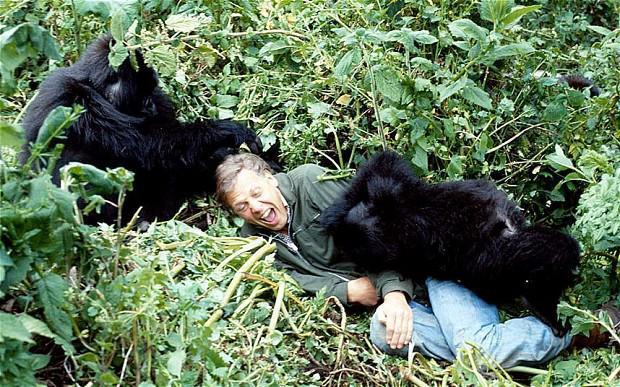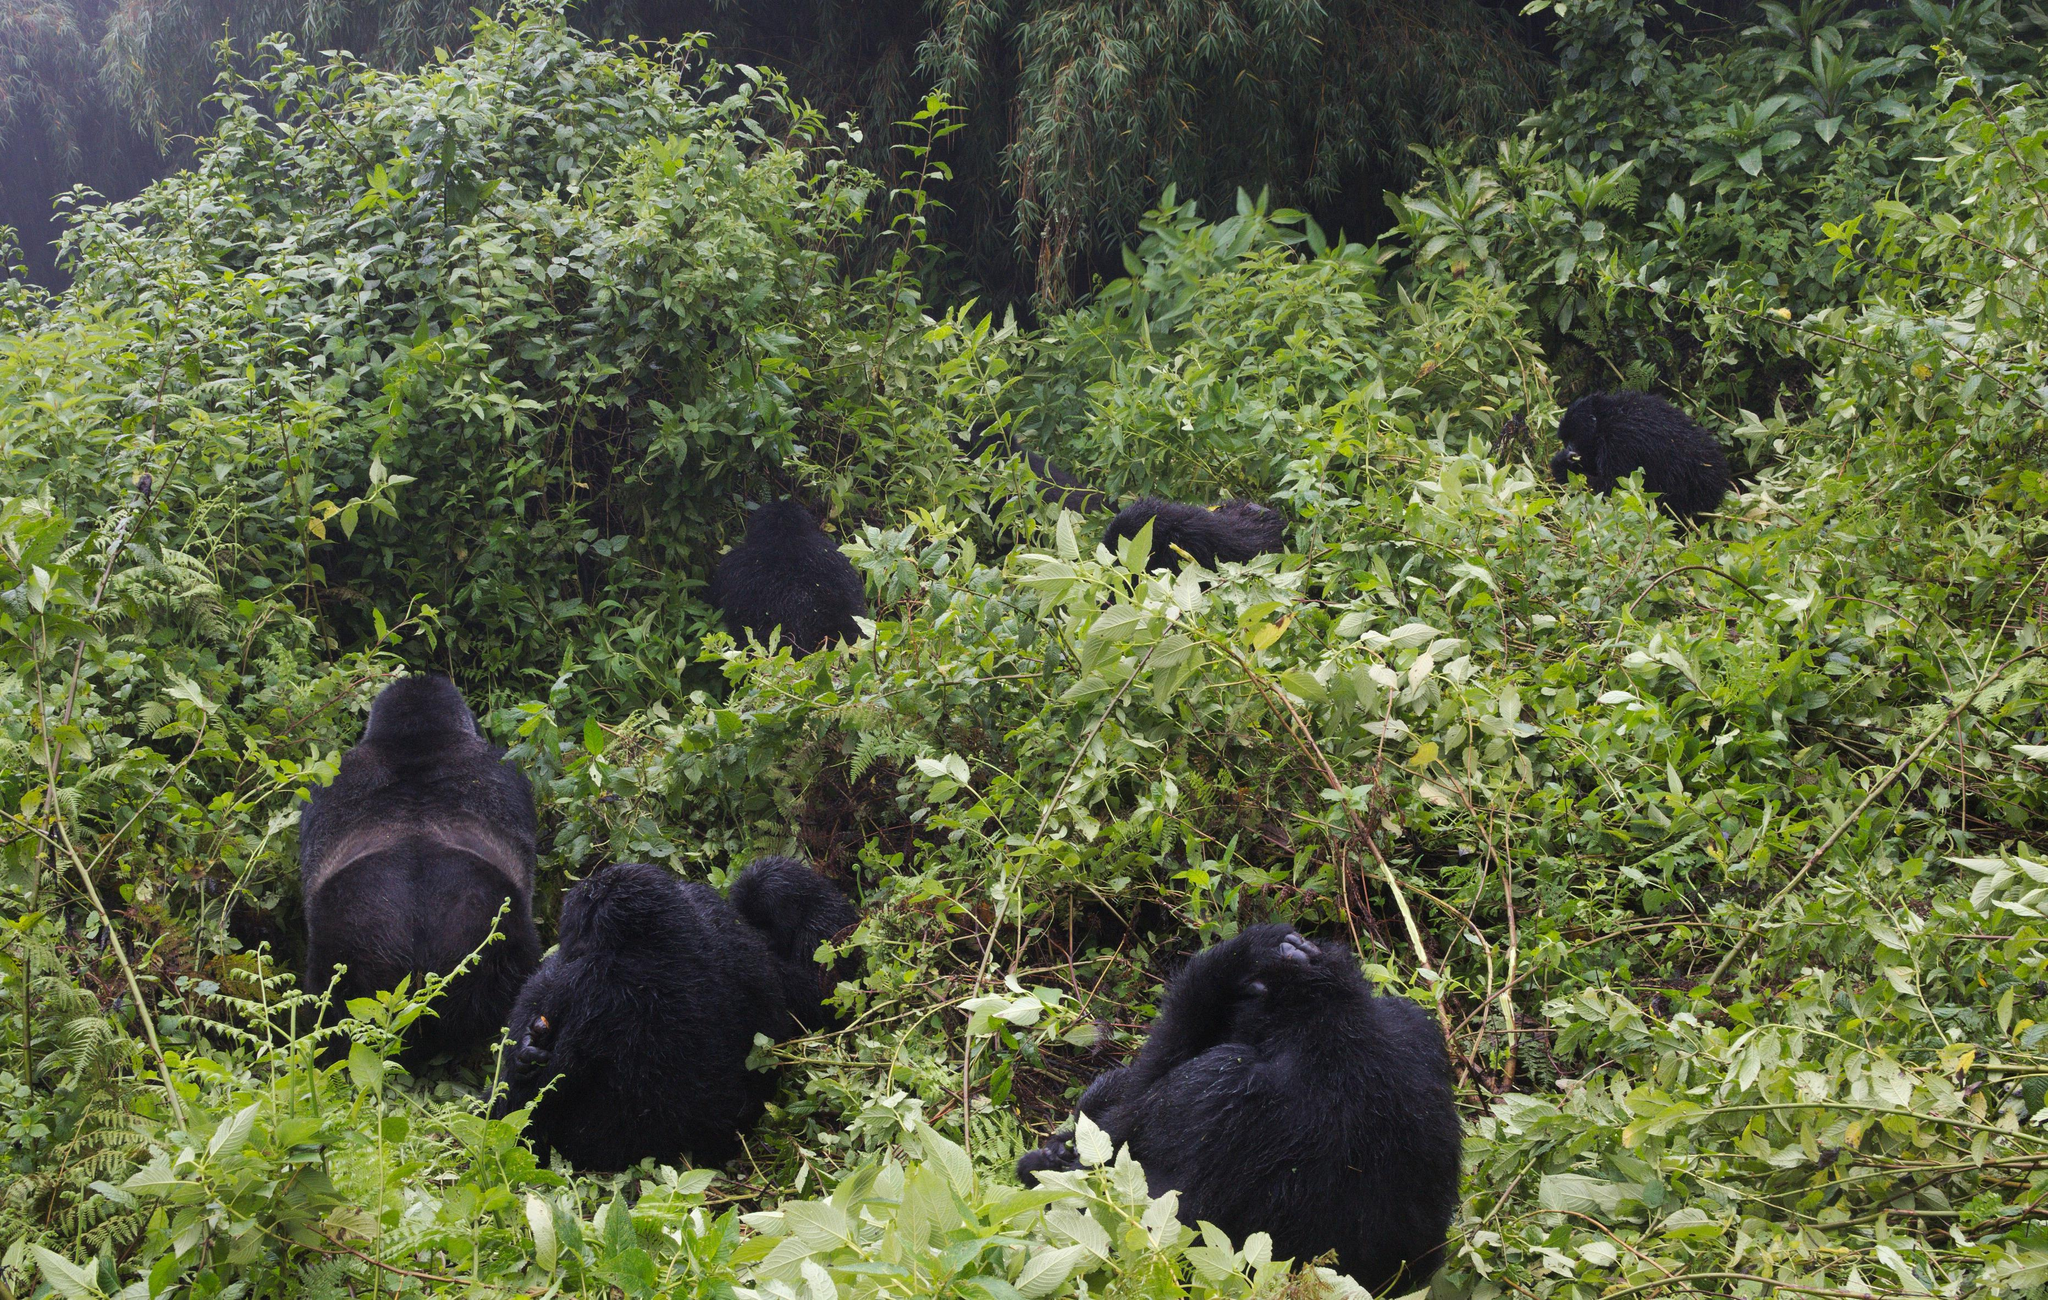The first image is the image on the left, the second image is the image on the right. Evaluate the accuracy of this statement regarding the images: "The right image contains no more than one gorilla.". Is it true? Answer yes or no. No. The first image is the image on the left, the second image is the image on the right. For the images displayed, is the sentence "The left image includes a rear-facing adult gorilla on all fours, with its body turned rightward and smaller gorillas around it." factually correct? Answer yes or no. No. 